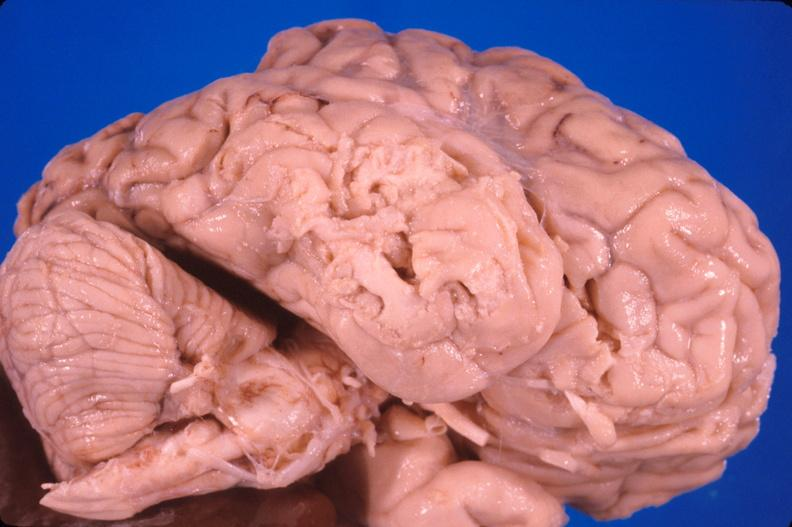what does this image show?
Answer the question using a single word or phrase. Brain 